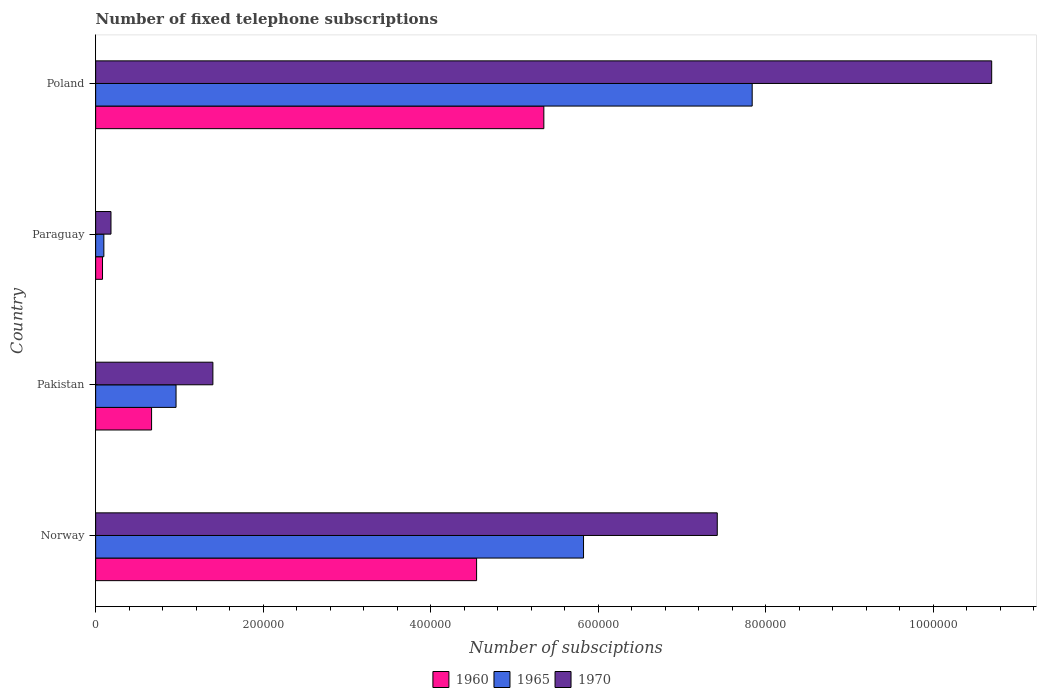How many different coloured bars are there?
Offer a terse response. 3. Are the number of bars per tick equal to the number of legend labels?
Your response must be concise. Yes. How many bars are there on the 2nd tick from the top?
Keep it short and to the point. 3. How many bars are there on the 2nd tick from the bottom?
Ensure brevity in your answer.  3. What is the label of the 2nd group of bars from the top?
Provide a succinct answer. Paraguay. What is the number of fixed telephone subscriptions in 1960 in Poland?
Ensure brevity in your answer.  5.35e+05. Across all countries, what is the maximum number of fixed telephone subscriptions in 1965?
Make the answer very short. 7.84e+05. Across all countries, what is the minimum number of fixed telephone subscriptions in 1970?
Your answer should be very brief. 1.83e+04. In which country was the number of fixed telephone subscriptions in 1960 maximum?
Provide a short and direct response. Poland. In which country was the number of fixed telephone subscriptions in 1970 minimum?
Make the answer very short. Paraguay. What is the total number of fixed telephone subscriptions in 1960 in the graph?
Offer a terse response. 1.07e+06. What is the difference between the number of fixed telephone subscriptions in 1965 in Norway and that in Poland?
Ensure brevity in your answer.  -2.01e+05. What is the difference between the number of fixed telephone subscriptions in 1965 in Poland and the number of fixed telephone subscriptions in 1960 in Paraguay?
Offer a terse response. 7.76e+05. What is the average number of fixed telephone subscriptions in 1960 per country?
Provide a short and direct response. 2.66e+05. What is the difference between the number of fixed telephone subscriptions in 1965 and number of fixed telephone subscriptions in 1970 in Norway?
Give a very brief answer. -1.60e+05. What is the ratio of the number of fixed telephone subscriptions in 1960 in Paraguay to that in Poland?
Keep it short and to the point. 0.02. Is the difference between the number of fixed telephone subscriptions in 1965 in Pakistan and Paraguay greater than the difference between the number of fixed telephone subscriptions in 1970 in Pakistan and Paraguay?
Your answer should be compact. No. What is the difference between the highest and the second highest number of fixed telephone subscriptions in 1970?
Make the answer very short. 3.28e+05. What is the difference between the highest and the lowest number of fixed telephone subscriptions in 1970?
Your response must be concise. 1.05e+06. What does the 2nd bar from the top in Pakistan represents?
Keep it short and to the point. 1965. What does the 3rd bar from the bottom in Poland represents?
Give a very brief answer. 1970. How many bars are there?
Ensure brevity in your answer.  12. Are all the bars in the graph horizontal?
Provide a succinct answer. Yes. Are the values on the major ticks of X-axis written in scientific E-notation?
Offer a terse response. No. Does the graph contain grids?
Your answer should be very brief. No. Where does the legend appear in the graph?
Keep it short and to the point. Bottom center. What is the title of the graph?
Offer a terse response. Number of fixed telephone subscriptions. What is the label or title of the X-axis?
Your answer should be very brief. Number of subsciptions. What is the label or title of the Y-axis?
Give a very brief answer. Country. What is the Number of subsciptions in 1960 in Norway?
Offer a terse response. 4.55e+05. What is the Number of subsciptions of 1965 in Norway?
Your answer should be compact. 5.83e+05. What is the Number of subsciptions in 1970 in Norway?
Provide a short and direct response. 7.42e+05. What is the Number of subsciptions of 1960 in Pakistan?
Keep it short and to the point. 6.68e+04. What is the Number of subsciptions in 1965 in Pakistan?
Provide a short and direct response. 9.60e+04. What is the Number of subsciptions of 1970 in Pakistan?
Ensure brevity in your answer.  1.40e+05. What is the Number of subsciptions of 1960 in Paraguay?
Offer a terse response. 8189. What is the Number of subsciptions in 1965 in Paraguay?
Keep it short and to the point. 9790. What is the Number of subsciptions in 1970 in Paraguay?
Your answer should be compact. 1.83e+04. What is the Number of subsciptions in 1960 in Poland?
Offer a very short reply. 5.35e+05. What is the Number of subsciptions in 1965 in Poland?
Provide a short and direct response. 7.84e+05. What is the Number of subsciptions of 1970 in Poland?
Provide a succinct answer. 1.07e+06. Across all countries, what is the maximum Number of subsciptions of 1960?
Your response must be concise. 5.35e+05. Across all countries, what is the maximum Number of subsciptions of 1965?
Keep it short and to the point. 7.84e+05. Across all countries, what is the maximum Number of subsciptions of 1970?
Your response must be concise. 1.07e+06. Across all countries, what is the minimum Number of subsciptions of 1960?
Provide a succinct answer. 8189. Across all countries, what is the minimum Number of subsciptions of 1965?
Ensure brevity in your answer.  9790. Across all countries, what is the minimum Number of subsciptions of 1970?
Provide a short and direct response. 1.83e+04. What is the total Number of subsciptions in 1960 in the graph?
Your answer should be compact. 1.07e+06. What is the total Number of subsciptions in 1965 in the graph?
Make the answer very short. 1.47e+06. What is the total Number of subsciptions of 1970 in the graph?
Offer a very short reply. 1.97e+06. What is the difference between the Number of subsciptions in 1960 in Norway and that in Pakistan?
Your answer should be very brief. 3.88e+05. What is the difference between the Number of subsciptions in 1965 in Norway and that in Pakistan?
Your answer should be very brief. 4.87e+05. What is the difference between the Number of subsciptions of 1970 in Norway and that in Pakistan?
Provide a succinct answer. 6.02e+05. What is the difference between the Number of subsciptions in 1960 in Norway and that in Paraguay?
Keep it short and to the point. 4.47e+05. What is the difference between the Number of subsciptions in 1965 in Norway and that in Paraguay?
Your response must be concise. 5.73e+05. What is the difference between the Number of subsciptions in 1970 in Norway and that in Paraguay?
Make the answer very short. 7.24e+05. What is the difference between the Number of subsciptions of 1960 in Norway and that in Poland?
Your answer should be compact. -8.03e+04. What is the difference between the Number of subsciptions in 1965 in Norway and that in Poland?
Ensure brevity in your answer.  -2.01e+05. What is the difference between the Number of subsciptions of 1970 in Norway and that in Poland?
Provide a short and direct response. -3.28e+05. What is the difference between the Number of subsciptions in 1960 in Pakistan and that in Paraguay?
Offer a terse response. 5.86e+04. What is the difference between the Number of subsciptions of 1965 in Pakistan and that in Paraguay?
Offer a terse response. 8.62e+04. What is the difference between the Number of subsciptions of 1970 in Pakistan and that in Paraguay?
Ensure brevity in your answer.  1.22e+05. What is the difference between the Number of subsciptions in 1960 in Pakistan and that in Poland?
Make the answer very short. -4.68e+05. What is the difference between the Number of subsciptions in 1965 in Pakistan and that in Poland?
Your response must be concise. -6.88e+05. What is the difference between the Number of subsciptions of 1970 in Pakistan and that in Poland?
Keep it short and to the point. -9.30e+05. What is the difference between the Number of subsciptions of 1960 in Paraguay and that in Poland?
Offer a very short reply. -5.27e+05. What is the difference between the Number of subsciptions of 1965 in Paraguay and that in Poland?
Your answer should be very brief. -7.74e+05. What is the difference between the Number of subsciptions of 1970 in Paraguay and that in Poland?
Ensure brevity in your answer.  -1.05e+06. What is the difference between the Number of subsciptions of 1960 in Norway and the Number of subsciptions of 1965 in Pakistan?
Ensure brevity in your answer.  3.59e+05. What is the difference between the Number of subsciptions in 1960 in Norway and the Number of subsciptions in 1970 in Pakistan?
Give a very brief answer. 3.15e+05. What is the difference between the Number of subsciptions in 1965 in Norway and the Number of subsciptions in 1970 in Pakistan?
Make the answer very short. 4.43e+05. What is the difference between the Number of subsciptions in 1960 in Norway and the Number of subsciptions in 1965 in Paraguay?
Provide a succinct answer. 4.45e+05. What is the difference between the Number of subsciptions in 1960 in Norway and the Number of subsciptions in 1970 in Paraguay?
Offer a terse response. 4.37e+05. What is the difference between the Number of subsciptions of 1965 in Norway and the Number of subsciptions of 1970 in Paraguay?
Offer a very short reply. 5.64e+05. What is the difference between the Number of subsciptions in 1960 in Norway and the Number of subsciptions in 1965 in Poland?
Provide a short and direct response. -3.29e+05. What is the difference between the Number of subsciptions of 1960 in Norway and the Number of subsciptions of 1970 in Poland?
Your response must be concise. -6.15e+05. What is the difference between the Number of subsciptions of 1965 in Norway and the Number of subsciptions of 1970 in Poland?
Keep it short and to the point. -4.87e+05. What is the difference between the Number of subsciptions of 1960 in Pakistan and the Number of subsciptions of 1965 in Paraguay?
Your response must be concise. 5.70e+04. What is the difference between the Number of subsciptions of 1960 in Pakistan and the Number of subsciptions of 1970 in Paraguay?
Provide a succinct answer. 4.85e+04. What is the difference between the Number of subsciptions in 1965 in Pakistan and the Number of subsciptions in 1970 in Paraguay?
Keep it short and to the point. 7.77e+04. What is the difference between the Number of subsciptions in 1960 in Pakistan and the Number of subsciptions in 1965 in Poland?
Your answer should be very brief. -7.17e+05. What is the difference between the Number of subsciptions of 1960 in Pakistan and the Number of subsciptions of 1970 in Poland?
Make the answer very short. -1.00e+06. What is the difference between the Number of subsciptions in 1965 in Pakistan and the Number of subsciptions in 1970 in Poland?
Your answer should be compact. -9.74e+05. What is the difference between the Number of subsciptions of 1960 in Paraguay and the Number of subsciptions of 1965 in Poland?
Provide a short and direct response. -7.76e+05. What is the difference between the Number of subsciptions in 1960 in Paraguay and the Number of subsciptions in 1970 in Poland?
Make the answer very short. -1.06e+06. What is the difference between the Number of subsciptions in 1965 in Paraguay and the Number of subsciptions in 1970 in Poland?
Your answer should be very brief. -1.06e+06. What is the average Number of subsciptions in 1960 per country?
Keep it short and to the point. 2.66e+05. What is the average Number of subsciptions in 1965 per country?
Provide a succinct answer. 3.68e+05. What is the average Number of subsciptions of 1970 per country?
Make the answer very short. 4.93e+05. What is the difference between the Number of subsciptions in 1960 and Number of subsciptions in 1965 in Norway?
Your response must be concise. -1.28e+05. What is the difference between the Number of subsciptions of 1960 and Number of subsciptions of 1970 in Norway?
Make the answer very short. -2.87e+05. What is the difference between the Number of subsciptions in 1965 and Number of subsciptions in 1970 in Norway?
Make the answer very short. -1.60e+05. What is the difference between the Number of subsciptions of 1960 and Number of subsciptions of 1965 in Pakistan?
Provide a short and direct response. -2.92e+04. What is the difference between the Number of subsciptions in 1960 and Number of subsciptions in 1970 in Pakistan?
Offer a very short reply. -7.32e+04. What is the difference between the Number of subsciptions in 1965 and Number of subsciptions in 1970 in Pakistan?
Give a very brief answer. -4.40e+04. What is the difference between the Number of subsciptions of 1960 and Number of subsciptions of 1965 in Paraguay?
Provide a short and direct response. -1601. What is the difference between the Number of subsciptions in 1960 and Number of subsciptions in 1970 in Paraguay?
Ensure brevity in your answer.  -1.01e+04. What is the difference between the Number of subsciptions in 1965 and Number of subsciptions in 1970 in Paraguay?
Keep it short and to the point. -8509. What is the difference between the Number of subsciptions in 1960 and Number of subsciptions in 1965 in Poland?
Keep it short and to the point. -2.49e+05. What is the difference between the Number of subsciptions of 1960 and Number of subsciptions of 1970 in Poland?
Provide a succinct answer. -5.35e+05. What is the difference between the Number of subsciptions of 1965 and Number of subsciptions of 1970 in Poland?
Provide a short and direct response. -2.86e+05. What is the ratio of the Number of subsciptions of 1960 in Norway to that in Pakistan?
Your answer should be very brief. 6.81. What is the ratio of the Number of subsciptions of 1965 in Norway to that in Pakistan?
Keep it short and to the point. 6.07. What is the ratio of the Number of subsciptions of 1970 in Norway to that in Pakistan?
Offer a terse response. 5.3. What is the ratio of the Number of subsciptions of 1960 in Norway to that in Paraguay?
Make the answer very short. 55.55. What is the ratio of the Number of subsciptions in 1965 in Norway to that in Paraguay?
Offer a terse response. 59.51. What is the ratio of the Number of subsciptions in 1970 in Norway to that in Paraguay?
Offer a very short reply. 40.57. What is the ratio of the Number of subsciptions of 1960 in Norway to that in Poland?
Ensure brevity in your answer.  0.85. What is the ratio of the Number of subsciptions in 1965 in Norway to that in Poland?
Ensure brevity in your answer.  0.74. What is the ratio of the Number of subsciptions of 1970 in Norway to that in Poland?
Ensure brevity in your answer.  0.69. What is the ratio of the Number of subsciptions in 1960 in Pakistan to that in Paraguay?
Your answer should be compact. 8.15. What is the ratio of the Number of subsciptions in 1965 in Pakistan to that in Paraguay?
Offer a terse response. 9.81. What is the ratio of the Number of subsciptions of 1970 in Pakistan to that in Paraguay?
Offer a terse response. 7.65. What is the ratio of the Number of subsciptions of 1960 in Pakistan to that in Poland?
Your response must be concise. 0.12. What is the ratio of the Number of subsciptions in 1965 in Pakistan to that in Poland?
Your answer should be very brief. 0.12. What is the ratio of the Number of subsciptions in 1970 in Pakistan to that in Poland?
Provide a succinct answer. 0.13. What is the ratio of the Number of subsciptions in 1960 in Paraguay to that in Poland?
Make the answer very short. 0.02. What is the ratio of the Number of subsciptions of 1965 in Paraguay to that in Poland?
Your answer should be very brief. 0.01. What is the ratio of the Number of subsciptions in 1970 in Paraguay to that in Poland?
Give a very brief answer. 0.02. What is the difference between the highest and the second highest Number of subsciptions of 1960?
Your answer should be compact. 8.03e+04. What is the difference between the highest and the second highest Number of subsciptions of 1965?
Offer a terse response. 2.01e+05. What is the difference between the highest and the second highest Number of subsciptions in 1970?
Your response must be concise. 3.28e+05. What is the difference between the highest and the lowest Number of subsciptions of 1960?
Make the answer very short. 5.27e+05. What is the difference between the highest and the lowest Number of subsciptions of 1965?
Your answer should be very brief. 7.74e+05. What is the difference between the highest and the lowest Number of subsciptions in 1970?
Give a very brief answer. 1.05e+06. 